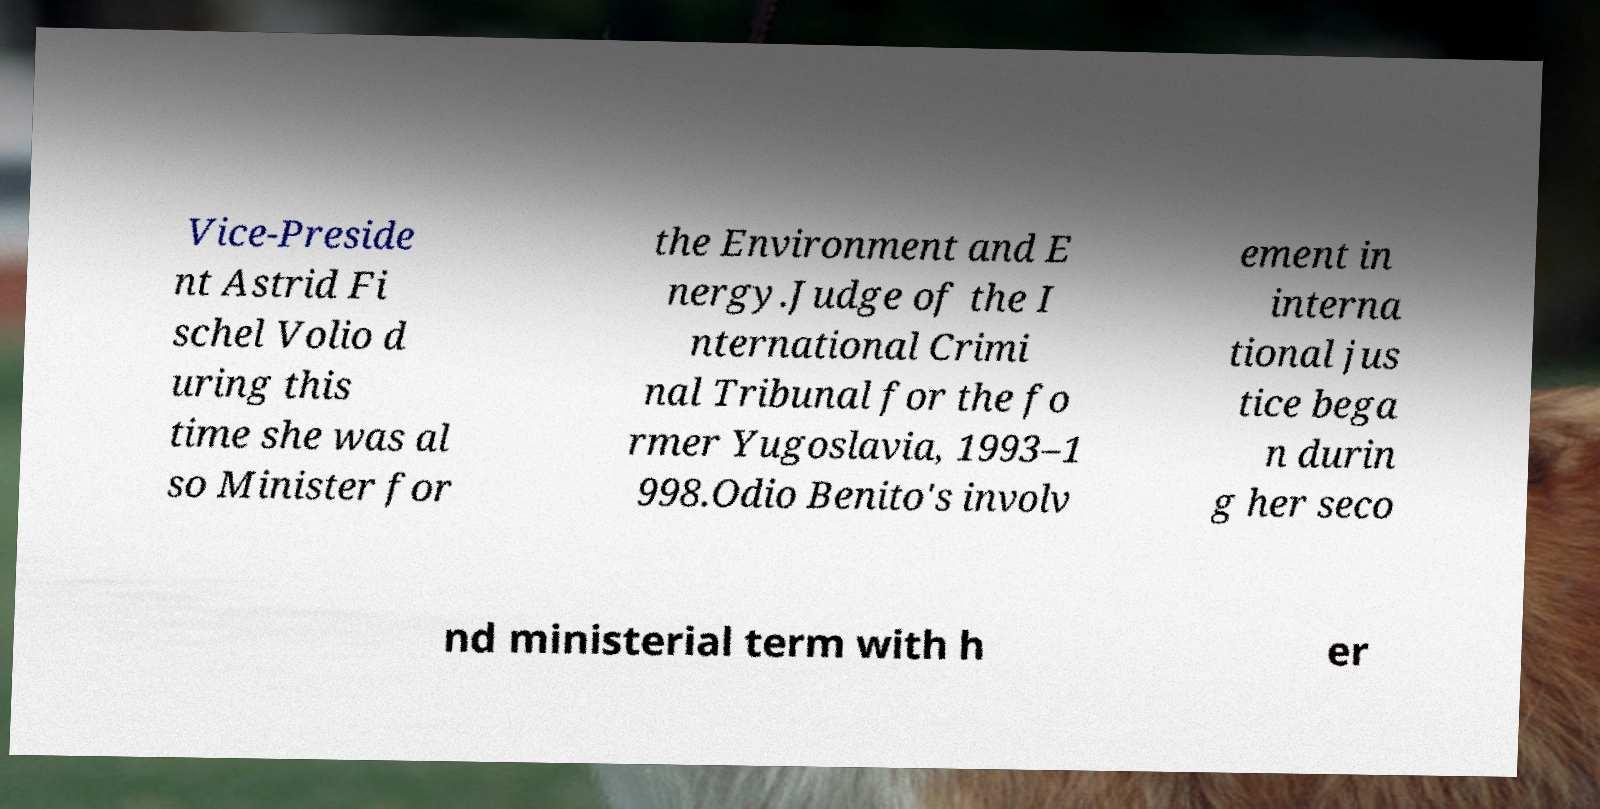Could you assist in decoding the text presented in this image and type it out clearly? Vice-Preside nt Astrid Fi schel Volio d uring this time she was al so Minister for the Environment and E nergy.Judge of the I nternational Crimi nal Tribunal for the fo rmer Yugoslavia, 1993–1 998.Odio Benito's involv ement in interna tional jus tice bega n durin g her seco nd ministerial term with h er 